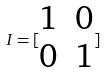<formula> <loc_0><loc_0><loc_500><loc_500>I = [ \begin{matrix} 1 & 0 \\ 0 & 1 \end{matrix} ]</formula> 